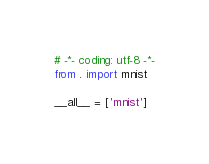<code> <loc_0><loc_0><loc_500><loc_500><_Python_># -*- coding: utf-8 -*-
from . import mnist

__all__ = ['mnist']
</code> 